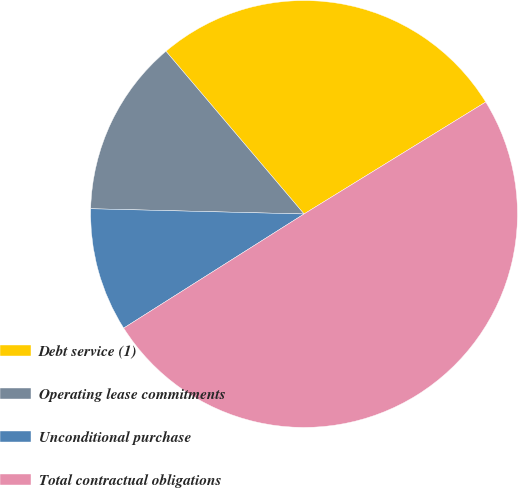<chart> <loc_0><loc_0><loc_500><loc_500><pie_chart><fcel>Debt service (1)<fcel>Operating lease commitments<fcel>Unconditional purchase<fcel>Total contractual obligations<nl><fcel>27.41%<fcel>13.41%<fcel>9.37%<fcel>49.81%<nl></chart> 